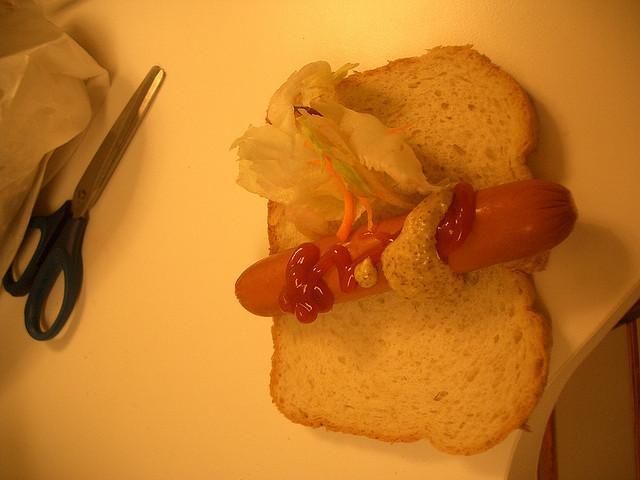How many different vegetables were used to create the red sauce on the hot dog? one 